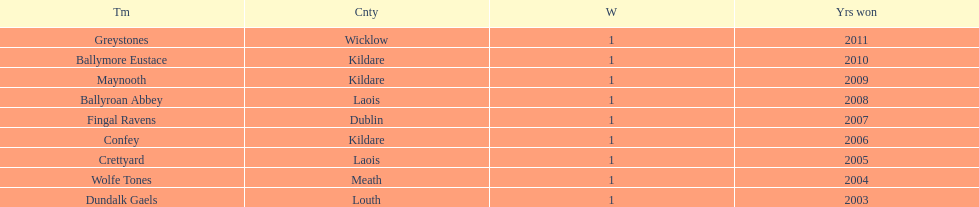What is the final team on the chart? Dundalk Gaels. 